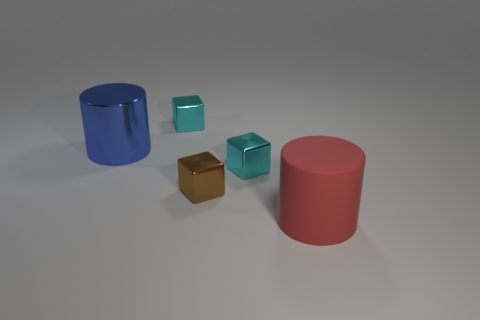What number of other things are there of the same size as the brown metal block?
Provide a short and direct response. 2. Do the metallic cylinder and the big matte thing have the same color?
Your answer should be very brief. No. There is a cyan metallic thing left of the small brown metallic block; does it have the same shape as the large rubber object?
Make the answer very short. No. How many things are both behind the matte cylinder and in front of the blue metallic cylinder?
Your answer should be compact. 2. What material is the big red object?
Offer a very short reply. Rubber. Are there any other things that are the same color as the big metallic cylinder?
Your answer should be compact. No. Is the large red cylinder made of the same material as the large blue object?
Offer a very short reply. No. How many red rubber objects are right of the small cyan block in front of the small block that is behind the blue shiny cylinder?
Your answer should be very brief. 1. How many big gray metal cylinders are there?
Your response must be concise. 0. Is the number of cyan shiny things in front of the red thing less than the number of large red cylinders behind the brown shiny thing?
Provide a succinct answer. No. 